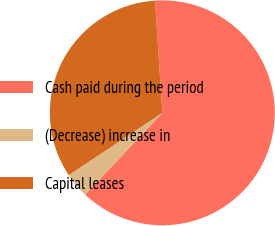Convert chart. <chart><loc_0><loc_0><loc_500><loc_500><pie_chart><fcel>Cash paid during the period<fcel>(Decrease) increase in<fcel>Capital leases<nl><fcel>63.06%<fcel>3.61%<fcel>33.33%<nl></chart> 